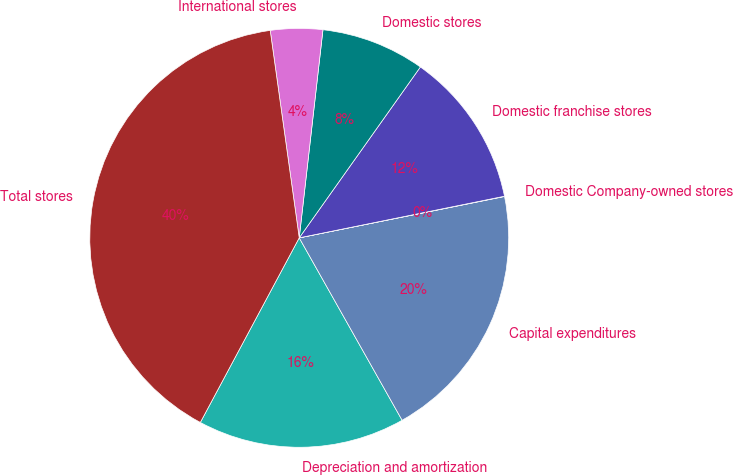<chart> <loc_0><loc_0><loc_500><loc_500><pie_chart><fcel>Depreciation and amortization<fcel>Capital expenditures<fcel>Domestic Company-owned stores<fcel>Domestic franchise stores<fcel>Domestic stores<fcel>International stores<fcel>Total stores<nl><fcel>16.0%<fcel>19.99%<fcel>0.02%<fcel>12.0%<fcel>8.01%<fcel>4.02%<fcel>39.96%<nl></chart> 